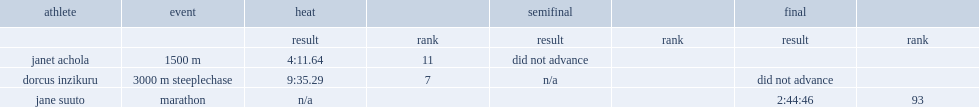What's the result of dorcus inzikuru in heat? 9:35.29. 